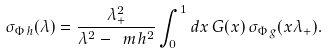Convert formula to latex. <formula><loc_0><loc_0><loc_500><loc_500>\sigma _ { \Phi \, h } ( \lambda ) = \frac { \lambda _ { + } ^ { 2 } } { \lambda ^ { 2 } - \ m h ^ { 2 } } \int _ { 0 } ^ { 1 } d x \, G ( x ) \, \sigma _ { \Phi \, g } ( x \lambda _ { + } ) .</formula> 